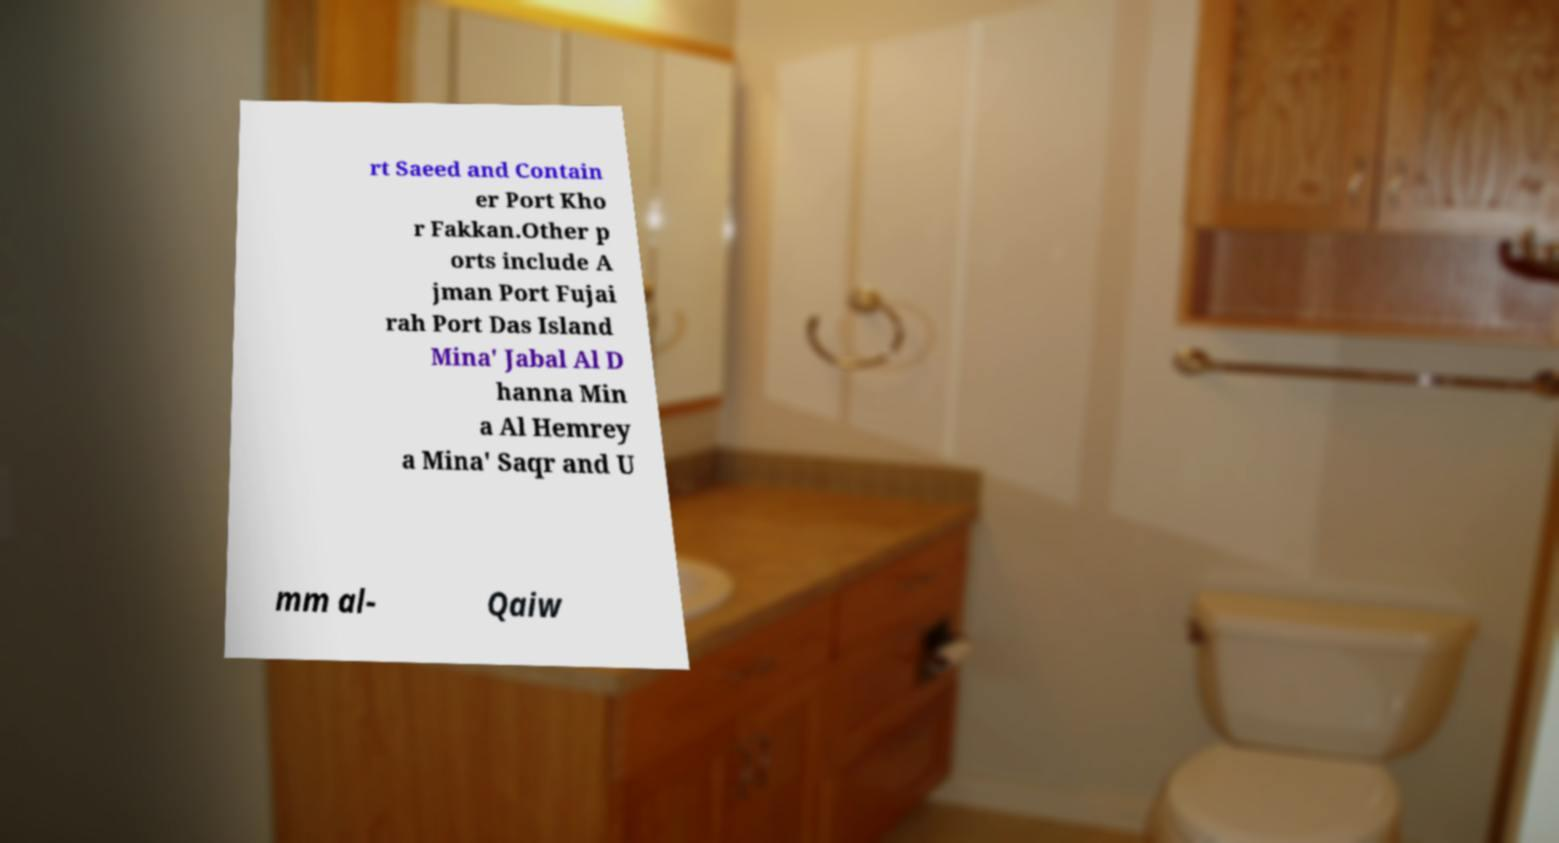I need the written content from this picture converted into text. Can you do that? rt Saeed and Contain er Port Kho r Fakkan.Other p orts include A jman Port Fujai rah Port Das Island Mina' Jabal Al D hanna Min a Al Hemrey a Mina' Saqr and U mm al- Qaiw 